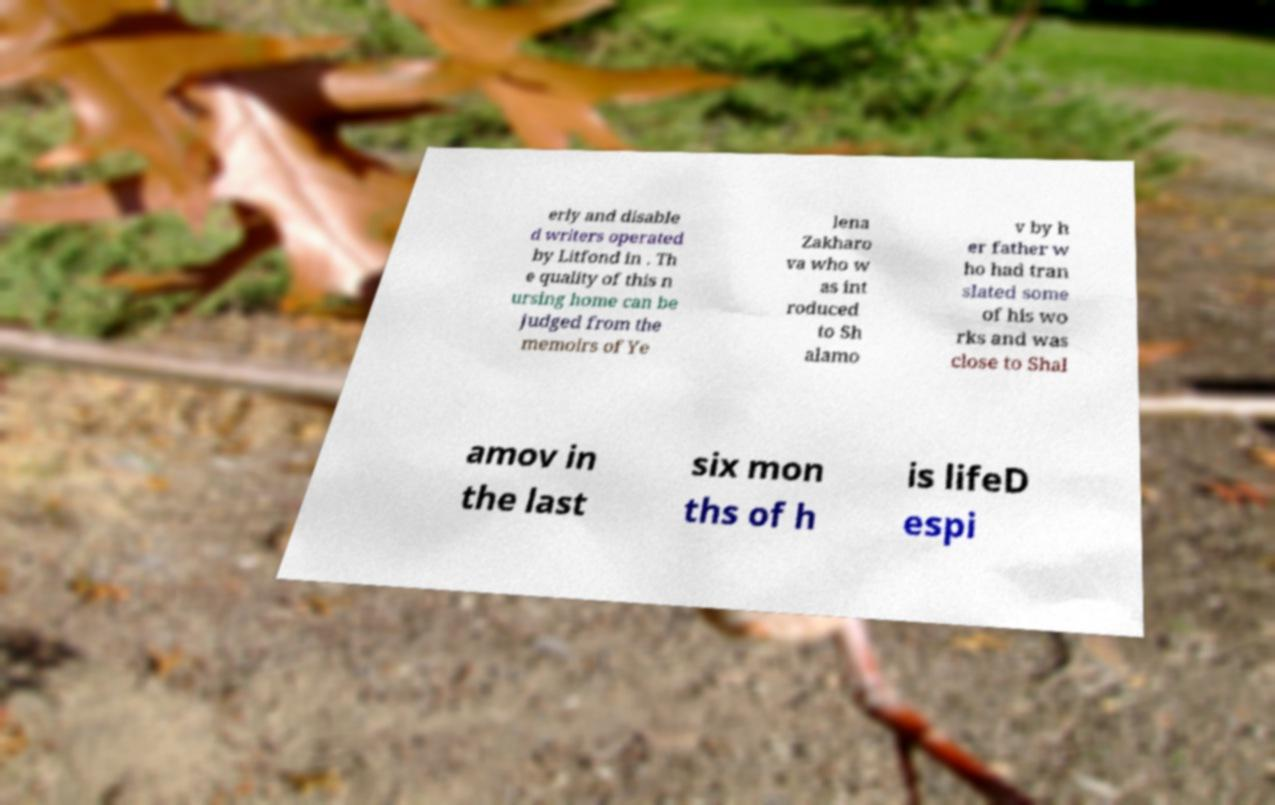What messages or text are displayed in this image? I need them in a readable, typed format. erly and disable d writers operated by Litfond in . Th e quality of this n ursing home can be judged from the memoirs of Ye lena Zakharo va who w as int roduced to Sh alamo v by h er father w ho had tran slated some of his wo rks and was close to Shal amov in the last six mon ths of h is lifeD espi 